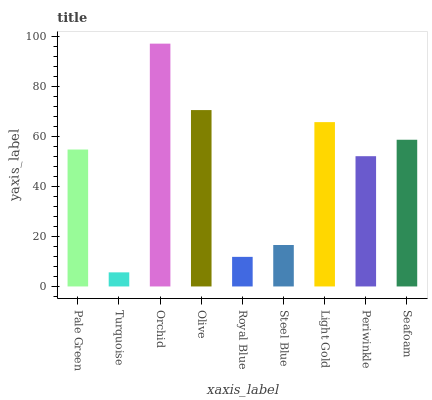Is Turquoise the minimum?
Answer yes or no. Yes. Is Orchid the maximum?
Answer yes or no. Yes. Is Orchid the minimum?
Answer yes or no. No. Is Turquoise the maximum?
Answer yes or no. No. Is Orchid greater than Turquoise?
Answer yes or no. Yes. Is Turquoise less than Orchid?
Answer yes or no. Yes. Is Turquoise greater than Orchid?
Answer yes or no. No. Is Orchid less than Turquoise?
Answer yes or no. No. Is Pale Green the high median?
Answer yes or no. Yes. Is Pale Green the low median?
Answer yes or no. Yes. Is Royal Blue the high median?
Answer yes or no. No. Is Olive the low median?
Answer yes or no. No. 